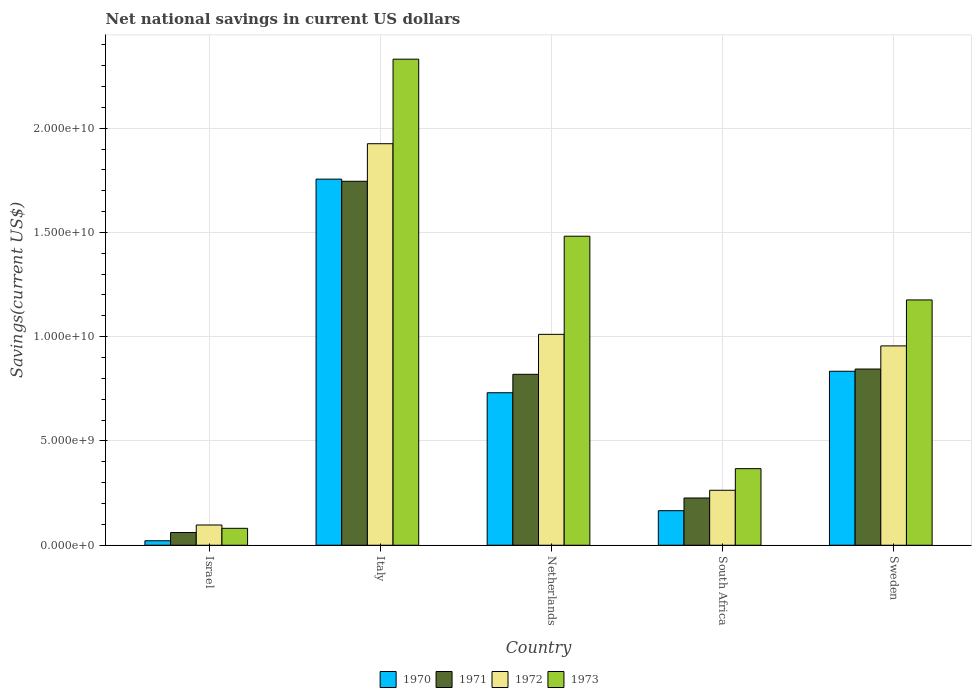How many groups of bars are there?
Provide a succinct answer. 5. Are the number of bars on each tick of the X-axis equal?
Keep it short and to the point. Yes. How many bars are there on the 1st tick from the left?
Give a very brief answer. 4. In how many cases, is the number of bars for a given country not equal to the number of legend labels?
Provide a succinct answer. 0. What is the net national savings in 1971 in Netherlands?
Your answer should be compact. 8.20e+09. Across all countries, what is the maximum net national savings in 1971?
Offer a terse response. 1.75e+1. Across all countries, what is the minimum net national savings in 1970?
Your answer should be very brief. 2.15e+08. In which country was the net national savings in 1972 maximum?
Provide a succinct answer. Italy. What is the total net national savings in 1971 in the graph?
Make the answer very short. 3.70e+1. What is the difference between the net national savings in 1972 in South Africa and that in Sweden?
Your response must be concise. -6.92e+09. What is the difference between the net national savings in 1973 in Netherlands and the net national savings in 1971 in Sweden?
Offer a terse response. 6.37e+09. What is the average net national savings in 1973 per country?
Your response must be concise. 1.09e+1. What is the difference between the net national savings of/in 1972 and net national savings of/in 1970 in Sweden?
Your answer should be very brief. 1.22e+09. What is the ratio of the net national savings in 1972 in Netherlands to that in Sweden?
Your answer should be very brief. 1.06. Is the net national savings in 1972 in Israel less than that in South Africa?
Your response must be concise. Yes. What is the difference between the highest and the second highest net national savings in 1970?
Provide a succinct answer. 9.21e+09. What is the difference between the highest and the lowest net national savings in 1973?
Ensure brevity in your answer.  2.25e+1. In how many countries, is the net national savings in 1972 greater than the average net national savings in 1972 taken over all countries?
Ensure brevity in your answer.  3. Is it the case that in every country, the sum of the net national savings in 1971 and net national savings in 1970 is greater than the sum of net national savings in 1972 and net national savings in 1973?
Your response must be concise. No. What does the 1st bar from the left in South Africa represents?
Offer a terse response. 1970. What does the 2nd bar from the right in Netherlands represents?
Your response must be concise. 1972. Are the values on the major ticks of Y-axis written in scientific E-notation?
Your answer should be compact. Yes. Does the graph contain grids?
Offer a very short reply. Yes. What is the title of the graph?
Offer a very short reply. Net national savings in current US dollars. What is the label or title of the Y-axis?
Your answer should be compact. Savings(current US$). What is the Savings(current US$) in 1970 in Israel?
Provide a succinct answer. 2.15e+08. What is the Savings(current US$) of 1971 in Israel?
Offer a terse response. 6.09e+08. What is the Savings(current US$) in 1972 in Israel?
Offer a terse response. 9.71e+08. What is the Savings(current US$) in 1973 in Israel?
Ensure brevity in your answer.  8.11e+08. What is the Savings(current US$) of 1970 in Italy?
Give a very brief answer. 1.76e+1. What is the Savings(current US$) of 1971 in Italy?
Your answer should be very brief. 1.75e+1. What is the Savings(current US$) of 1972 in Italy?
Provide a succinct answer. 1.93e+1. What is the Savings(current US$) in 1973 in Italy?
Your response must be concise. 2.33e+1. What is the Savings(current US$) in 1970 in Netherlands?
Make the answer very short. 7.31e+09. What is the Savings(current US$) in 1971 in Netherlands?
Give a very brief answer. 8.20e+09. What is the Savings(current US$) of 1972 in Netherlands?
Your response must be concise. 1.01e+1. What is the Savings(current US$) of 1973 in Netherlands?
Ensure brevity in your answer.  1.48e+1. What is the Savings(current US$) in 1970 in South Africa?
Offer a terse response. 1.66e+09. What is the Savings(current US$) of 1971 in South Africa?
Your response must be concise. 2.27e+09. What is the Savings(current US$) of 1972 in South Africa?
Keep it short and to the point. 2.64e+09. What is the Savings(current US$) of 1973 in South Africa?
Your response must be concise. 3.67e+09. What is the Savings(current US$) of 1970 in Sweden?
Keep it short and to the point. 8.34e+09. What is the Savings(current US$) of 1971 in Sweden?
Your response must be concise. 8.45e+09. What is the Savings(current US$) of 1972 in Sweden?
Keep it short and to the point. 9.56e+09. What is the Savings(current US$) in 1973 in Sweden?
Ensure brevity in your answer.  1.18e+1. Across all countries, what is the maximum Savings(current US$) in 1970?
Your answer should be compact. 1.76e+1. Across all countries, what is the maximum Savings(current US$) in 1971?
Provide a short and direct response. 1.75e+1. Across all countries, what is the maximum Savings(current US$) of 1972?
Ensure brevity in your answer.  1.93e+1. Across all countries, what is the maximum Savings(current US$) in 1973?
Your response must be concise. 2.33e+1. Across all countries, what is the minimum Savings(current US$) of 1970?
Your response must be concise. 2.15e+08. Across all countries, what is the minimum Savings(current US$) in 1971?
Offer a terse response. 6.09e+08. Across all countries, what is the minimum Savings(current US$) of 1972?
Offer a very short reply. 9.71e+08. Across all countries, what is the minimum Savings(current US$) of 1973?
Ensure brevity in your answer.  8.11e+08. What is the total Savings(current US$) of 1970 in the graph?
Give a very brief answer. 3.51e+1. What is the total Savings(current US$) in 1971 in the graph?
Your answer should be very brief. 3.70e+1. What is the total Savings(current US$) of 1972 in the graph?
Ensure brevity in your answer.  4.25e+1. What is the total Savings(current US$) in 1973 in the graph?
Provide a short and direct response. 5.44e+1. What is the difference between the Savings(current US$) in 1970 in Israel and that in Italy?
Provide a succinct answer. -1.73e+1. What is the difference between the Savings(current US$) in 1971 in Israel and that in Italy?
Your answer should be compact. -1.68e+1. What is the difference between the Savings(current US$) in 1972 in Israel and that in Italy?
Keep it short and to the point. -1.83e+1. What is the difference between the Savings(current US$) of 1973 in Israel and that in Italy?
Your response must be concise. -2.25e+1. What is the difference between the Savings(current US$) of 1970 in Israel and that in Netherlands?
Your answer should be compact. -7.10e+09. What is the difference between the Savings(current US$) in 1971 in Israel and that in Netherlands?
Provide a succinct answer. -7.59e+09. What is the difference between the Savings(current US$) of 1972 in Israel and that in Netherlands?
Your response must be concise. -9.14e+09. What is the difference between the Savings(current US$) of 1973 in Israel and that in Netherlands?
Offer a terse response. -1.40e+1. What is the difference between the Savings(current US$) in 1970 in Israel and that in South Africa?
Your answer should be very brief. -1.44e+09. What is the difference between the Savings(current US$) in 1971 in Israel and that in South Africa?
Your answer should be very brief. -1.66e+09. What is the difference between the Savings(current US$) of 1972 in Israel and that in South Africa?
Offer a very short reply. -1.66e+09. What is the difference between the Savings(current US$) in 1973 in Israel and that in South Africa?
Offer a terse response. -2.86e+09. What is the difference between the Savings(current US$) in 1970 in Israel and that in Sweden?
Ensure brevity in your answer.  -8.13e+09. What is the difference between the Savings(current US$) in 1971 in Israel and that in Sweden?
Offer a very short reply. -7.84e+09. What is the difference between the Savings(current US$) of 1972 in Israel and that in Sweden?
Provide a succinct answer. -8.59e+09. What is the difference between the Savings(current US$) of 1973 in Israel and that in Sweden?
Your answer should be compact. -1.10e+1. What is the difference between the Savings(current US$) of 1970 in Italy and that in Netherlands?
Offer a terse response. 1.02e+1. What is the difference between the Savings(current US$) of 1971 in Italy and that in Netherlands?
Offer a terse response. 9.26e+09. What is the difference between the Savings(current US$) in 1972 in Italy and that in Netherlands?
Give a very brief answer. 9.14e+09. What is the difference between the Savings(current US$) in 1973 in Italy and that in Netherlands?
Provide a succinct answer. 8.49e+09. What is the difference between the Savings(current US$) in 1970 in Italy and that in South Africa?
Offer a very short reply. 1.59e+1. What is the difference between the Savings(current US$) of 1971 in Italy and that in South Africa?
Ensure brevity in your answer.  1.52e+1. What is the difference between the Savings(current US$) of 1972 in Italy and that in South Africa?
Ensure brevity in your answer.  1.66e+1. What is the difference between the Savings(current US$) of 1973 in Italy and that in South Africa?
Provide a succinct answer. 1.96e+1. What is the difference between the Savings(current US$) in 1970 in Italy and that in Sweden?
Give a very brief answer. 9.21e+09. What is the difference between the Savings(current US$) in 1971 in Italy and that in Sweden?
Offer a terse response. 9.00e+09. What is the difference between the Savings(current US$) in 1972 in Italy and that in Sweden?
Provide a succinct answer. 9.70e+09. What is the difference between the Savings(current US$) of 1973 in Italy and that in Sweden?
Offer a terse response. 1.15e+1. What is the difference between the Savings(current US$) in 1970 in Netherlands and that in South Africa?
Your answer should be compact. 5.66e+09. What is the difference between the Savings(current US$) of 1971 in Netherlands and that in South Africa?
Keep it short and to the point. 5.93e+09. What is the difference between the Savings(current US$) of 1972 in Netherlands and that in South Africa?
Provide a succinct answer. 7.48e+09. What is the difference between the Savings(current US$) of 1973 in Netherlands and that in South Africa?
Offer a terse response. 1.11e+1. What is the difference between the Savings(current US$) of 1970 in Netherlands and that in Sweden?
Your answer should be compact. -1.03e+09. What is the difference between the Savings(current US$) of 1971 in Netherlands and that in Sweden?
Your answer should be compact. -2.53e+08. What is the difference between the Savings(current US$) of 1972 in Netherlands and that in Sweden?
Give a very brief answer. 5.54e+08. What is the difference between the Savings(current US$) in 1973 in Netherlands and that in Sweden?
Your answer should be very brief. 3.06e+09. What is the difference between the Savings(current US$) of 1970 in South Africa and that in Sweden?
Make the answer very short. -6.69e+09. What is the difference between the Savings(current US$) in 1971 in South Africa and that in Sweden?
Make the answer very short. -6.18e+09. What is the difference between the Savings(current US$) in 1972 in South Africa and that in Sweden?
Offer a very short reply. -6.92e+09. What is the difference between the Savings(current US$) in 1973 in South Africa and that in Sweden?
Your answer should be very brief. -8.09e+09. What is the difference between the Savings(current US$) of 1970 in Israel and the Savings(current US$) of 1971 in Italy?
Offer a terse response. -1.72e+1. What is the difference between the Savings(current US$) in 1970 in Israel and the Savings(current US$) in 1972 in Italy?
Your response must be concise. -1.90e+1. What is the difference between the Savings(current US$) of 1970 in Israel and the Savings(current US$) of 1973 in Italy?
Provide a short and direct response. -2.31e+1. What is the difference between the Savings(current US$) in 1971 in Israel and the Savings(current US$) in 1972 in Italy?
Ensure brevity in your answer.  -1.86e+1. What is the difference between the Savings(current US$) of 1971 in Israel and the Savings(current US$) of 1973 in Italy?
Make the answer very short. -2.27e+1. What is the difference between the Savings(current US$) in 1972 in Israel and the Savings(current US$) in 1973 in Italy?
Give a very brief answer. -2.23e+1. What is the difference between the Savings(current US$) in 1970 in Israel and the Savings(current US$) in 1971 in Netherlands?
Provide a short and direct response. -7.98e+09. What is the difference between the Savings(current US$) in 1970 in Israel and the Savings(current US$) in 1972 in Netherlands?
Ensure brevity in your answer.  -9.90e+09. What is the difference between the Savings(current US$) in 1970 in Israel and the Savings(current US$) in 1973 in Netherlands?
Give a very brief answer. -1.46e+1. What is the difference between the Savings(current US$) of 1971 in Israel and the Savings(current US$) of 1972 in Netherlands?
Your answer should be compact. -9.50e+09. What is the difference between the Savings(current US$) of 1971 in Israel and the Savings(current US$) of 1973 in Netherlands?
Make the answer very short. -1.42e+1. What is the difference between the Savings(current US$) of 1972 in Israel and the Savings(current US$) of 1973 in Netherlands?
Provide a succinct answer. -1.38e+1. What is the difference between the Savings(current US$) of 1970 in Israel and the Savings(current US$) of 1971 in South Africa?
Keep it short and to the point. -2.05e+09. What is the difference between the Savings(current US$) in 1970 in Israel and the Savings(current US$) in 1972 in South Africa?
Your answer should be very brief. -2.42e+09. What is the difference between the Savings(current US$) in 1970 in Israel and the Savings(current US$) in 1973 in South Africa?
Your response must be concise. -3.46e+09. What is the difference between the Savings(current US$) in 1971 in Israel and the Savings(current US$) in 1972 in South Africa?
Offer a terse response. -2.03e+09. What is the difference between the Savings(current US$) of 1971 in Israel and the Savings(current US$) of 1973 in South Africa?
Give a very brief answer. -3.06e+09. What is the difference between the Savings(current US$) in 1972 in Israel and the Savings(current US$) in 1973 in South Africa?
Your answer should be very brief. -2.70e+09. What is the difference between the Savings(current US$) in 1970 in Israel and the Savings(current US$) in 1971 in Sweden?
Offer a very short reply. -8.23e+09. What is the difference between the Savings(current US$) in 1970 in Israel and the Savings(current US$) in 1972 in Sweden?
Provide a short and direct response. -9.34e+09. What is the difference between the Savings(current US$) in 1970 in Israel and the Savings(current US$) in 1973 in Sweden?
Provide a short and direct response. -1.15e+1. What is the difference between the Savings(current US$) of 1971 in Israel and the Savings(current US$) of 1972 in Sweden?
Provide a succinct answer. -8.95e+09. What is the difference between the Savings(current US$) of 1971 in Israel and the Savings(current US$) of 1973 in Sweden?
Provide a succinct answer. -1.12e+1. What is the difference between the Savings(current US$) of 1972 in Israel and the Savings(current US$) of 1973 in Sweden?
Provide a succinct answer. -1.08e+1. What is the difference between the Savings(current US$) of 1970 in Italy and the Savings(current US$) of 1971 in Netherlands?
Make the answer very short. 9.36e+09. What is the difference between the Savings(current US$) of 1970 in Italy and the Savings(current US$) of 1972 in Netherlands?
Offer a terse response. 7.44e+09. What is the difference between the Savings(current US$) of 1970 in Italy and the Savings(current US$) of 1973 in Netherlands?
Your response must be concise. 2.74e+09. What is the difference between the Savings(current US$) in 1971 in Italy and the Savings(current US$) in 1972 in Netherlands?
Your response must be concise. 7.34e+09. What is the difference between the Savings(current US$) in 1971 in Italy and the Savings(current US$) in 1973 in Netherlands?
Give a very brief answer. 2.63e+09. What is the difference between the Savings(current US$) in 1972 in Italy and the Savings(current US$) in 1973 in Netherlands?
Keep it short and to the point. 4.44e+09. What is the difference between the Savings(current US$) of 1970 in Italy and the Savings(current US$) of 1971 in South Africa?
Your response must be concise. 1.53e+1. What is the difference between the Savings(current US$) in 1970 in Italy and the Savings(current US$) in 1972 in South Africa?
Your response must be concise. 1.49e+1. What is the difference between the Savings(current US$) of 1970 in Italy and the Savings(current US$) of 1973 in South Africa?
Give a very brief answer. 1.39e+1. What is the difference between the Savings(current US$) of 1971 in Italy and the Savings(current US$) of 1972 in South Africa?
Offer a very short reply. 1.48e+1. What is the difference between the Savings(current US$) of 1971 in Italy and the Savings(current US$) of 1973 in South Africa?
Your answer should be compact. 1.38e+1. What is the difference between the Savings(current US$) of 1972 in Italy and the Savings(current US$) of 1973 in South Africa?
Keep it short and to the point. 1.56e+1. What is the difference between the Savings(current US$) of 1970 in Italy and the Savings(current US$) of 1971 in Sweden?
Provide a short and direct response. 9.11e+09. What is the difference between the Savings(current US$) of 1970 in Italy and the Savings(current US$) of 1972 in Sweden?
Keep it short and to the point. 8.00e+09. What is the difference between the Savings(current US$) in 1970 in Italy and the Savings(current US$) in 1973 in Sweden?
Your answer should be very brief. 5.79e+09. What is the difference between the Savings(current US$) of 1971 in Italy and the Savings(current US$) of 1972 in Sweden?
Make the answer very short. 7.89e+09. What is the difference between the Savings(current US$) of 1971 in Italy and the Savings(current US$) of 1973 in Sweden?
Offer a very short reply. 5.69e+09. What is the difference between the Savings(current US$) of 1972 in Italy and the Savings(current US$) of 1973 in Sweden?
Provide a succinct answer. 7.49e+09. What is the difference between the Savings(current US$) of 1970 in Netherlands and the Savings(current US$) of 1971 in South Africa?
Your answer should be compact. 5.05e+09. What is the difference between the Savings(current US$) in 1970 in Netherlands and the Savings(current US$) in 1972 in South Africa?
Your response must be concise. 4.68e+09. What is the difference between the Savings(current US$) of 1970 in Netherlands and the Savings(current US$) of 1973 in South Africa?
Your response must be concise. 3.64e+09. What is the difference between the Savings(current US$) of 1971 in Netherlands and the Savings(current US$) of 1972 in South Africa?
Make the answer very short. 5.56e+09. What is the difference between the Savings(current US$) of 1971 in Netherlands and the Savings(current US$) of 1973 in South Africa?
Give a very brief answer. 4.52e+09. What is the difference between the Savings(current US$) of 1972 in Netherlands and the Savings(current US$) of 1973 in South Africa?
Provide a short and direct response. 6.44e+09. What is the difference between the Savings(current US$) in 1970 in Netherlands and the Savings(current US$) in 1971 in Sweden?
Provide a short and direct response. -1.14e+09. What is the difference between the Savings(current US$) in 1970 in Netherlands and the Savings(current US$) in 1972 in Sweden?
Ensure brevity in your answer.  -2.25e+09. What is the difference between the Savings(current US$) of 1970 in Netherlands and the Savings(current US$) of 1973 in Sweden?
Ensure brevity in your answer.  -4.45e+09. What is the difference between the Savings(current US$) of 1971 in Netherlands and the Savings(current US$) of 1972 in Sweden?
Ensure brevity in your answer.  -1.36e+09. What is the difference between the Savings(current US$) of 1971 in Netherlands and the Savings(current US$) of 1973 in Sweden?
Give a very brief answer. -3.57e+09. What is the difference between the Savings(current US$) of 1972 in Netherlands and the Savings(current US$) of 1973 in Sweden?
Make the answer very short. -1.65e+09. What is the difference between the Savings(current US$) in 1970 in South Africa and the Savings(current US$) in 1971 in Sweden?
Keep it short and to the point. -6.79e+09. What is the difference between the Savings(current US$) in 1970 in South Africa and the Savings(current US$) in 1972 in Sweden?
Provide a short and direct response. -7.90e+09. What is the difference between the Savings(current US$) of 1970 in South Africa and the Savings(current US$) of 1973 in Sweden?
Offer a terse response. -1.01e+1. What is the difference between the Savings(current US$) in 1971 in South Africa and the Savings(current US$) in 1972 in Sweden?
Provide a short and direct response. -7.29e+09. What is the difference between the Savings(current US$) of 1971 in South Africa and the Savings(current US$) of 1973 in Sweden?
Give a very brief answer. -9.50e+09. What is the difference between the Savings(current US$) of 1972 in South Africa and the Savings(current US$) of 1973 in Sweden?
Offer a terse response. -9.13e+09. What is the average Savings(current US$) in 1970 per country?
Keep it short and to the point. 7.02e+09. What is the average Savings(current US$) in 1971 per country?
Make the answer very short. 7.39e+09. What is the average Savings(current US$) of 1972 per country?
Offer a terse response. 8.51e+09. What is the average Savings(current US$) in 1973 per country?
Your answer should be very brief. 1.09e+1. What is the difference between the Savings(current US$) in 1970 and Savings(current US$) in 1971 in Israel?
Offer a very short reply. -3.94e+08. What is the difference between the Savings(current US$) in 1970 and Savings(current US$) in 1972 in Israel?
Make the answer very short. -7.56e+08. What is the difference between the Savings(current US$) of 1970 and Savings(current US$) of 1973 in Israel?
Make the answer very short. -5.96e+08. What is the difference between the Savings(current US$) in 1971 and Savings(current US$) in 1972 in Israel?
Make the answer very short. -3.62e+08. What is the difference between the Savings(current US$) of 1971 and Savings(current US$) of 1973 in Israel?
Provide a succinct answer. -2.02e+08. What is the difference between the Savings(current US$) of 1972 and Savings(current US$) of 1973 in Israel?
Ensure brevity in your answer.  1.60e+08. What is the difference between the Savings(current US$) in 1970 and Savings(current US$) in 1971 in Italy?
Your answer should be compact. 1.03e+08. What is the difference between the Savings(current US$) of 1970 and Savings(current US$) of 1972 in Italy?
Your answer should be compact. -1.70e+09. What is the difference between the Savings(current US$) of 1970 and Savings(current US$) of 1973 in Italy?
Offer a very short reply. -5.75e+09. What is the difference between the Savings(current US$) of 1971 and Savings(current US$) of 1972 in Italy?
Make the answer very short. -1.80e+09. What is the difference between the Savings(current US$) in 1971 and Savings(current US$) in 1973 in Italy?
Provide a succinct answer. -5.86e+09. What is the difference between the Savings(current US$) in 1972 and Savings(current US$) in 1973 in Italy?
Make the answer very short. -4.05e+09. What is the difference between the Savings(current US$) of 1970 and Savings(current US$) of 1971 in Netherlands?
Provide a succinct answer. -8.83e+08. What is the difference between the Savings(current US$) in 1970 and Savings(current US$) in 1972 in Netherlands?
Provide a succinct answer. -2.80e+09. What is the difference between the Savings(current US$) in 1970 and Savings(current US$) in 1973 in Netherlands?
Provide a short and direct response. -7.51e+09. What is the difference between the Savings(current US$) in 1971 and Savings(current US$) in 1972 in Netherlands?
Your answer should be compact. -1.92e+09. What is the difference between the Savings(current US$) in 1971 and Savings(current US$) in 1973 in Netherlands?
Give a very brief answer. -6.62e+09. What is the difference between the Savings(current US$) in 1972 and Savings(current US$) in 1973 in Netherlands?
Provide a succinct answer. -4.71e+09. What is the difference between the Savings(current US$) of 1970 and Savings(current US$) of 1971 in South Africa?
Make the answer very short. -6.09e+08. What is the difference between the Savings(current US$) in 1970 and Savings(current US$) in 1972 in South Africa?
Provide a succinct answer. -9.79e+08. What is the difference between the Savings(current US$) in 1970 and Savings(current US$) in 1973 in South Africa?
Make the answer very short. -2.02e+09. What is the difference between the Savings(current US$) of 1971 and Savings(current US$) of 1972 in South Africa?
Offer a very short reply. -3.70e+08. What is the difference between the Savings(current US$) in 1971 and Savings(current US$) in 1973 in South Africa?
Provide a short and direct response. -1.41e+09. What is the difference between the Savings(current US$) of 1972 and Savings(current US$) of 1973 in South Africa?
Provide a short and direct response. -1.04e+09. What is the difference between the Savings(current US$) in 1970 and Savings(current US$) in 1971 in Sweden?
Your response must be concise. -1.07e+08. What is the difference between the Savings(current US$) in 1970 and Savings(current US$) in 1972 in Sweden?
Offer a very short reply. -1.22e+09. What is the difference between the Savings(current US$) in 1970 and Savings(current US$) in 1973 in Sweden?
Ensure brevity in your answer.  -3.42e+09. What is the difference between the Savings(current US$) in 1971 and Savings(current US$) in 1972 in Sweden?
Offer a terse response. -1.11e+09. What is the difference between the Savings(current US$) in 1971 and Savings(current US$) in 1973 in Sweden?
Your response must be concise. -3.31e+09. What is the difference between the Savings(current US$) in 1972 and Savings(current US$) in 1973 in Sweden?
Provide a succinct answer. -2.20e+09. What is the ratio of the Savings(current US$) of 1970 in Israel to that in Italy?
Provide a short and direct response. 0.01. What is the ratio of the Savings(current US$) in 1971 in Israel to that in Italy?
Provide a succinct answer. 0.03. What is the ratio of the Savings(current US$) of 1972 in Israel to that in Italy?
Provide a short and direct response. 0.05. What is the ratio of the Savings(current US$) of 1973 in Israel to that in Italy?
Give a very brief answer. 0.03. What is the ratio of the Savings(current US$) of 1970 in Israel to that in Netherlands?
Give a very brief answer. 0.03. What is the ratio of the Savings(current US$) in 1971 in Israel to that in Netherlands?
Keep it short and to the point. 0.07. What is the ratio of the Savings(current US$) in 1972 in Israel to that in Netherlands?
Your answer should be compact. 0.1. What is the ratio of the Savings(current US$) of 1973 in Israel to that in Netherlands?
Give a very brief answer. 0.05. What is the ratio of the Savings(current US$) in 1970 in Israel to that in South Africa?
Keep it short and to the point. 0.13. What is the ratio of the Savings(current US$) in 1971 in Israel to that in South Africa?
Offer a very short reply. 0.27. What is the ratio of the Savings(current US$) of 1972 in Israel to that in South Africa?
Provide a short and direct response. 0.37. What is the ratio of the Savings(current US$) of 1973 in Israel to that in South Africa?
Offer a very short reply. 0.22. What is the ratio of the Savings(current US$) of 1970 in Israel to that in Sweden?
Your response must be concise. 0.03. What is the ratio of the Savings(current US$) of 1971 in Israel to that in Sweden?
Provide a succinct answer. 0.07. What is the ratio of the Savings(current US$) in 1972 in Israel to that in Sweden?
Give a very brief answer. 0.1. What is the ratio of the Savings(current US$) in 1973 in Israel to that in Sweden?
Offer a terse response. 0.07. What is the ratio of the Savings(current US$) of 1970 in Italy to that in Netherlands?
Offer a terse response. 2.4. What is the ratio of the Savings(current US$) in 1971 in Italy to that in Netherlands?
Your answer should be very brief. 2.13. What is the ratio of the Savings(current US$) in 1972 in Italy to that in Netherlands?
Your response must be concise. 1.9. What is the ratio of the Savings(current US$) of 1973 in Italy to that in Netherlands?
Provide a short and direct response. 1.57. What is the ratio of the Savings(current US$) of 1970 in Italy to that in South Africa?
Your answer should be very brief. 10.6. What is the ratio of the Savings(current US$) in 1971 in Italy to that in South Africa?
Give a very brief answer. 7.7. What is the ratio of the Savings(current US$) of 1972 in Italy to that in South Africa?
Give a very brief answer. 7.31. What is the ratio of the Savings(current US$) in 1973 in Italy to that in South Africa?
Ensure brevity in your answer.  6.35. What is the ratio of the Savings(current US$) of 1970 in Italy to that in Sweden?
Offer a terse response. 2.1. What is the ratio of the Savings(current US$) of 1971 in Italy to that in Sweden?
Make the answer very short. 2.07. What is the ratio of the Savings(current US$) of 1972 in Italy to that in Sweden?
Your answer should be compact. 2.01. What is the ratio of the Savings(current US$) in 1973 in Italy to that in Sweden?
Your response must be concise. 1.98. What is the ratio of the Savings(current US$) in 1970 in Netherlands to that in South Africa?
Your response must be concise. 4.42. What is the ratio of the Savings(current US$) in 1971 in Netherlands to that in South Africa?
Provide a succinct answer. 3.62. What is the ratio of the Savings(current US$) of 1972 in Netherlands to that in South Africa?
Offer a terse response. 3.84. What is the ratio of the Savings(current US$) in 1973 in Netherlands to that in South Africa?
Keep it short and to the point. 4.04. What is the ratio of the Savings(current US$) in 1970 in Netherlands to that in Sweden?
Ensure brevity in your answer.  0.88. What is the ratio of the Savings(current US$) of 1972 in Netherlands to that in Sweden?
Your answer should be very brief. 1.06. What is the ratio of the Savings(current US$) of 1973 in Netherlands to that in Sweden?
Give a very brief answer. 1.26. What is the ratio of the Savings(current US$) in 1970 in South Africa to that in Sweden?
Make the answer very short. 0.2. What is the ratio of the Savings(current US$) of 1971 in South Africa to that in Sweden?
Make the answer very short. 0.27. What is the ratio of the Savings(current US$) in 1972 in South Africa to that in Sweden?
Provide a succinct answer. 0.28. What is the ratio of the Savings(current US$) in 1973 in South Africa to that in Sweden?
Offer a very short reply. 0.31. What is the difference between the highest and the second highest Savings(current US$) of 1970?
Give a very brief answer. 9.21e+09. What is the difference between the highest and the second highest Savings(current US$) of 1971?
Make the answer very short. 9.00e+09. What is the difference between the highest and the second highest Savings(current US$) in 1972?
Offer a very short reply. 9.14e+09. What is the difference between the highest and the second highest Savings(current US$) of 1973?
Offer a terse response. 8.49e+09. What is the difference between the highest and the lowest Savings(current US$) in 1970?
Offer a very short reply. 1.73e+1. What is the difference between the highest and the lowest Savings(current US$) of 1971?
Offer a terse response. 1.68e+1. What is the difference between the highest and the lowest Savings(current US$) in 1972?
Provide a succinct answer. 1.83e+1. What is the difference between the highest and the lowest Savings(current US$) in 1973?
Ensure brevity in your answer.  2.25e+1. 